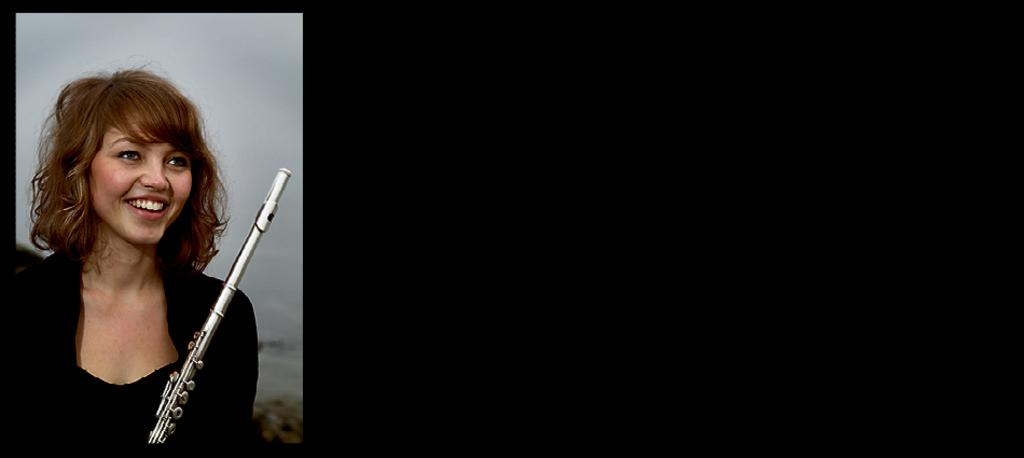Who is the main subject in the image? There is a woman in the image. What is the woman wearing? The woman is wearing a black dress. What is the woman holding in the image? The woman is holding a musical instrument. What is the woman's facial expression? The woman is smiling. What type of light can be seen coming from the crate in the image? There is no crate present in the image, so it is not possible to determine if there is any light coming from it. 